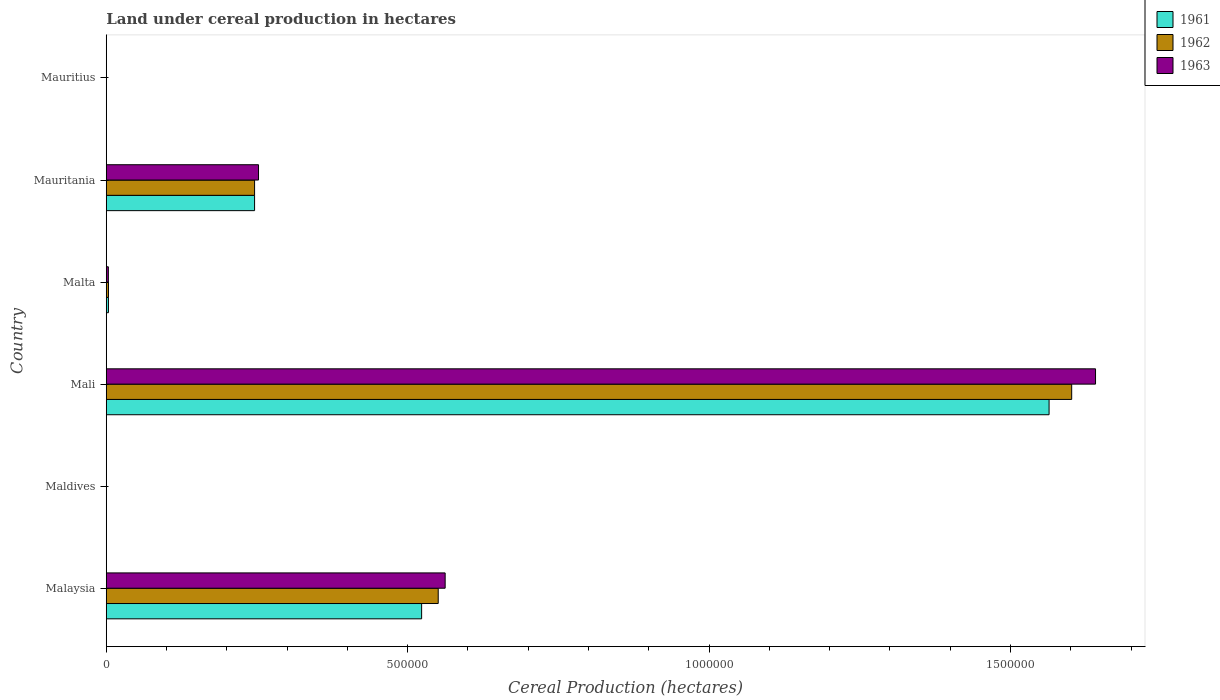How many groups of bars are there?
Your response must be concise. 6. Are the number of bars per tick equal to the number of legend labels?
Offer a very short reply. Yes. Are the number of bars on each tick of the Y-axis equal?
Ensure brevity in your answer.  Yes. How many bars are there on the 4th tick from the bottom?
Ensure brevity in your answer.  3. What is the label of the 6th group of bars from the top?
Give a very brief answer. Malaysia. What is the land under cereal production in 1962 in Maldives?
Your answer should be very brief. 240. Across all countries, what is the maximum land under cereal production in 1962?
Your response must be concise. 1.60e+06. Across all countries, what is the minimum land under cereal production in 1962?
Ensure brevity in your answer.  114. In which country was the land under cereal production in 1961 maximum?
Offer a terse response. Mali. In which country was the land under cereal production in 1961 minimum?
Offer a very short reply. Mauritius. What is the total land under cereal production in 1962 in the graph?
Offer a very short reply. 2.40e+06. What is the difference between the land under cereal production in 1961 in Mali and that in Mauritania?
Keep it short and to the point. 1.32e+06. What is the difference between the land under cereal production in 1963 in Mauritania and the land under cereal production in 1961 in Maldives?
Provide a short and direct response. 2.52e+05. What is the average land under cereal production in 1962 per country?
Your answer should be compact. 4.00e+05. What is the ratio of the land under cereal production in 1963 in Maldives to that in Mauritania?
Offer a terse response. 0. What is the difference between the highest and the second highest land under cereal production in 1961?
Keep it short and to the point. 1.04e+06. What is the difference between the highest and the lowest land under cereal production in 1961?
Keep it short and to the point. 1.56e+06. What does the 1st bar from the top in Maldives represents?
Make the answer very short. 1963. What does the 1st bar from the bottom in Mauritania represents?
Provide a short and direct response. 1961. How many bars are there?
Give a very brief answer. 18. How many countries are there in the graph?
Your answer should be compact. 6. Are the values on the major ticks of X-axis written in scientific E-notation?
Provide a succinct answer. No. Where does the legend appear in the graph?
Provide a succinct answer. Top right. What is the title of the graph?
Offer a terse response. Land under cereal production in hectares. What is the label or title of the X-axis?
Your answer should be very brief. Cereal Production (hectares). What is the Cereal Production (hectares) of 1961 in Malaysia?
Provide a short and direct response. 5.23e+05. What is the Cereal Production (hectares) in 1962 in Malaysia?
Ensure brevity in your answer.  5.51e+05. What is the Cereal Production (hectares) in 1963 in Malaysia?
Offer a terse response. 5.62e+05. What is the Cereal Production (hectares) in 1961 in Maldives?
Provide a succinct answer. 179. What is the Cereal Production (hectares) in 1962 in Maldives?
Your answer should be very brief. 240. What is the Cereal Production (hectares) of 1963 in Maldives?
Give a very brief answer. 292. What is the Cereal Production (hectares) of 1961 in Mali?
Offer a terse response. 1.56e+06. What is the Cereal Production (hectares) in 1962 in Mali?
Provide a short and direct response. 1.60e+06. What is the Cereal Production (hectares) of 1963 in Mali?
Offer a terse response. 1.64e+06. What is the Cereal Production (hectares) of 1961 in Malta?
Provide a short and direct response. 3649. What is the Cereal Production (hectares) of 1962 in Malta?
Offer a terse response. 3699. What is the Cereal Production (hectares) in 1963 in Malta?
Offer a terse response. 3513. What is the Cereal Production (hectares) of 1961 in Mauritania?
Give a very brief answer. 2.46e+05. What is the Cereal Production (hectares) in 1962 in Mauritania?
Your answer should be compact. 2.46e+05. What is the Cereal Production (hectares) of 1963 in Mauritania?
Ensure brevity in your answer.  2.53e+05. What is the Cereal Production (hectares) of 1961 in Mauritius?
Provide a succinct answer. 119. What is the Cereal Production (hectares) in 1962 in Mauritius?
Your answer should be compact. 114. What is the Cereal Production (hectares) of 1963 in Mauritius?
Make the answer very short. 114. Across all countries, what is the maximum Cereal Production (hectares) of 1961?
Ensure brevity in your answer.  1.56e+06. Across all countries, what is the maximum Cereal Production (hectares) of 1962?
Provide a short and direct response. 1.60e+06. Across all countries, what is the maximum Cereal Production (hectares) in 1963?
Your response must be concise. 1.64e+06. Across all countries, what is the minimum Cereal Production (hectares) in 1961?
Provide a succinct answer. 119. Across all countries, what is the minimum Cereal Production (hectares) of 1962?
Offer a terse response. 114. Across all countries, what is the minimum Cereal Production (hectares) of 1963?
Provide a short and direct response. 114. What is the total Cereal Production (hectares) of 1961 in the graph?
Offer a terse response. 2.34e+06. What is the total Cereal Production (hectares) in 1962 in the graph?
Make the answer very short. 2.40e+06. What is the total Cereal Production (hectares) of 1963 in the graph?
Give a very brief answer. 2.46e+06. What is the difference between the Cereal Production (hectares) of 1961 in Malaysia and that in Maldives?
Keep it short and to the point. 5.23e+05. What is the difference between the Cereal Production (hectares) in 1962 in Malaysia and that in Maldives?
Your response must be concise. 5.50e+05. What is the difference between the Cereal Production (hectares) of 1963 in Malaysia and that in Maldives?
Your answer should be very brief. 5.62e+05. What is the difference between the Cereal Production (hectares) in 1961 in Malaysia and that in Mali?
Provide a succinct answer. -1.04e+06. What is the difference between the Cereal Production (hectares) of 1962 in Malaysia and that in Mali?
Provide a succinct answer. -1.05e+06. What is the difference between the Cereal Production (hectares) of 1963 in Malaysia and that in Mali?
Make the answer very short. -1.08e+06. What is the difference between the Cereal Production (hectares) in 1961 in Malaysia and that in Malta?
Give a very brief answer. 5.20e+05. What is the difference between the Cereal Production (hectares) of 1962 in Malaysia and that in Malta?
Keep it short and to the point. 5.47e+05. What is the difference between the Cereal Production (hectares) of 1963 in Malaysia and that in Malta?
Provide a succinct answer. 5.59e+05. What is the difference between the Cereal Production (hectares) in 1961 in Malaysia and that in Mauritania?
Your answer should be very brief. 2.77e+05. What is the difference between the Cereal Production (hectares) in 1962 in Malaysia and that in Mauritania?
Offer a very short reply. 3.05e+05. What is the difference between the Cereal Production (hectares) of 1963 in Malaysia and that in Mauritania?
Give a very brief answer. 3.10e+05. What is the difference between the Cereal Production (hectares) in 1961 in Malaysia and that in Mauritius?
Your answer should be very brief. 5.23e+05. What is the difference between the Cereal Production (hectares) in 1962 in Malaysia and that in Mauritius?
Give a very brief answer. 5.51e+05. What is the difference between the Cereal Production (hectares) of 1963 in Malaysia and that in Mauritius?
Your answer should be very brief. 5.62e+05. What is the difference between the Cereal Production (hectares) in 1961 in Maldives and that in Mali?
Ensure brevity in your answer.  -1.56e+06. What is the difference between the Cereal Production (hectares) of 1962 in Maldives and that in Mali?
Make the answer very short. -1.60e+06. What is the difference between the Cereal Production (hectares) in 1963 in Maldives and that in Mali?
Offer a very short reply. -1.64e+06. What is the difference between the Cereal Production (hectares) of 1961 in Maldives and that in Malta?
Provide a succinct answer. -3470. What is the difference between the Cereal Production (hectares) in 1962 in Maldives and that in Malta?
Your answer should be very brief. -3459. What is the difference between the Cereal Production (hectares) of 1963 in Maldives and that in Malta?
Keep it short and to the point. -3221. What is the difference between the Cereal Production (hectares) in 1961 in Maldives and that in Mauritania?
Keep it short and to the point. -2.46e+05. What is the difference between the Cereal Production (hectares) in 1962 in Maldives and that in Mauritania?
Your response must be concise. -2.46e+05. What is the difference between the Cereal Production (hectares) of 1963 in Maldives and that in Mauritania?
Offer a very short reply. -2.52e+05. What is the difference between the Cereal Production (hectares) of 1962 in Maldives and that in Mauritius?
Your response must be concise. 126. What is the difference between the Cereal Production (hectares) in 1963 in Maldives and that in Mauritius?
Keep it short and to the point. 178. What is the difference between the Cereal Production (hectares) of 1961 in Mali and that in Malta?
Provide a short and direct response. 1.56e+06. What is the difference between the Cereal Production (hectares) in 1962 in Mali and that in Malta?
Offer a very short reply. 1.60e+06. What is the difference between the Cereal Production (hectares) of 1963 in Mali and that in Malta?
Your response must be concise. 1.64e+06. What is the difference between the Cereal Production (hectares) in 1961 in Mali and that in Mauritania?
Ensure brevity in your answer.  1.32e+06. What is the difference between the Cereal Production (hectares) of 1962 in Mali and that in Mauritania?
Offer a very short reply. 1.36e+06. What is the difference between the Cereal Production (hectares) in 1963 in Mali and that in Mauritania?
Your response must be concise. 1.39e+06. What is the difference between the Cereal Production (hectares) of 1961 in Mali and that in Mauritius?
Provide a succinct answer. 1.56e+06. What is the difference between the Cereal Production (hectares) in 1962 in Mali and that in Mauritius?
Keep it short and to the point. 1.60e+06. What is the difference between the Cereal Production (hectares) in 1963 in Mali and that in Mauritius?
Provide a succinct answer. 1.64e+06. What is the difference between the Cereal Production (hectares) in 1961 in Malta and that in Mauritania?
Give a very brief answer. -2.42e+05. What is the difference between the Cereal Production (hectares) in 1962 in Malta and that in Mauritania?
Give a very brief answer. -2.42e+05. What is the difference between the Cereal Production (hectares) in 1963 in Malta and that in Mauritania?
Make the answer very short. -2.49e+05. What is the difference between the Cereal Production (hectares) of 1961 in Malta and that in Mauritius?
Provide a succinct answer. 3530. What is the difference between the Cereal Production (hectares) in 1962 in Malta and that in Mauritius?
Give a very brief answer. 3585. What is the difference between the Cereal Production (hectares) in 1963 in Malta and that in Mauritius?
Provide a succinct answer. 3399. What is the difference between the Cereal Production (hectares) in 1961 in Mauritania and that in Mauritius?
Give a very brief answer. 2.46e+05. What is the difference between the Cereal Production (hectares) of 1962 in Mauritania and that in Mauritius?
Provide a short and direct response. 2.46e+05. What is the difference between the Cereal Production (hectares) in 1963 in Mauritania and that in Mauritius?
Offer a very short reply. 2.52e+05. What is the difference between the Cereal Production (hectares) of 1961 in Malaysia and the Cereal Production (hectares) of 1962 in Maldives?
Provide a succinct answer. 5.23e+05. What is the difference between the Cereal Production (hectares) in 1961 in Malaysia and the Cereal Production (hectares) in 1963 in Maldives?
Provide a succinct answer. 5.23e+05. What is the difference between the Cereal Production (hectares) of 1962 in Malaysia and the Cereal Production (hectares) of 1963 in Maldives?
Your answer should be very brief. 5.50e+05. What is the difference between the Cereal Production (hectares) in 1961 in Malaysia and the Cereal Production (hectares) in 1962 in Mali?
Keep it short and to the point. -1.08e+06. What is the difference between the Cereal Production (hectares) of 1961 in Malaysia and the Cereal Production (hectares) of 1963 in Mali?
Ensure brevity in your answer.  -1.12e+06. What is the difference between the Cereal Production (hectares) in 1962 in Malaysia and the Cereal Production (hectares) in 1963 in Mali?
Make the answer very short. -1.09e+06. What is the difference between the Cereal Production (hectares) in 1961 in Malaysia and the Cereal Production (hectares) in 1962 in Malta?
Provide a succinct answer. 5.19e+05. What is the difference between the Cereal Production (hectares) in 1961 in Malaysia and the Cereal Production (hectares) in 1963 in Malta?
Your answer should be compact. 5.20e+05. What is the difference between the Cereal Production (hectares) of 1962 in Malaysia and the Cereal Production (hectares) of 1963 in Malta?
Your answer should be very brief. 5.47e+05. What is the difference between the Cereal Production (hectares) in 1961 in Malaysia and the Cereal Production (hectares) in 1962 in Mauritania?
Offer a very short reply. 2.77e+05. What is the difference between the Cereal Production (hectares) of 1961 in Malaysia and the Cereal Production (hectares) of 1963 in Mauritania?
Provide a short and direct response. 2.71e+05. What is the difference between the Cereal Production (hectares) in 1962 in Malaysia and the Cereal Production (hectares) in 1963 in Mauritania?
Ensure brevity in your answer.  2.98e+05. What is the difference between the Cereal Production (hectares) in 1961 in Malaysia and the Cereal Production (hectares) in 1962 in Mauritius?
Keep it short and to the point. 5.23e+05. What is the difference between the Cereal Production (hectares) in 1961 in Malaysia and the Cereal Production (hectares) in 1963 in Mauritius?
Your answer should be very brief. 5.23e+05. What is the difference between the Cereal Production (hectares) in 1962 in Malaysia and the Cereal Production (hectares) in 1963 in Mauritius?
Provide a short and direct response. 5.51e+05. What is the difference between the Cereal Production (hectares) in 1961 in Maldives and the Cereal Production (hectares) in 1962 in Mali?
Provide a short and direct response. -1.60e+06. What is the difference between the Cereal Production (hectares) of 1961 in Maldives and the Cereal Production (hectares) of 1963 in Mali?
Make the answer very short. -1.64e+06. What is the difference between the Cereal Production (hectares) of 1962 in Maldives and the Cereal Production (hectares) of 1963 in Mali?
Keep it short and to the point. -1.64e+06. What is the difference between the Cereal Production (hectares) of 1961 in Maldives and the Cereal Production (hectares) of 1962 in Malta?
Offer a very short reply. -3520. What is the difference between the Cereal Production (hectares) of 1961 in Maldives and the Cereal Production (hectares) of 1963 in Malta?
Ensure brevity in your answer.  -3334. What is the difference between the Cereal Production (hectares) in 1962 in Maldives and the Cereal Production (hectares) in 1963 in Malta?
Your answer should be compact. -3273. What is the difference between the Cereal Production (hectares) of 1961 in Maldives and the Cereal Production (hectares) of 1962 in Mauritania?
Offer a terse response. -2.46e+05. What is the difference between the Cereal Production (hectares) of 1961 in Maldives and the Cereal Production (hectares) of 1963 in Mauritania?
Keep it short and to the point. -2.52e+05. What is the difference between the Cereal Production (hectares) in 1962 in Maldives and the Cereal Production (hectares) in 1963 in Mauritania?
Keep it short and to the point. -2.52e+05. What is the difference between the Cereal Production (hectares) of 1961 in Maldives and the Cereal Production (hectares) of 1962 in Mauritius?
Make the answer very short. 65. What is the difference between the Cereal Production (hectares) in 1962 in Maldives and the Cereal Production (hectares) in 1963 in Mauritius?
Give a very brief answer. 126. What is the difference between the Cereal Production (hectares) of 1961 in Mali and the Cereal Production (hectares) of 1962 in Malta?
Ensure brevity in your answer.  1.56e+06. What is the difference between the Cereal Production (hectares) of 1961 in Mali and the Cereal Production (hectares) of 1963 in Malta?
Provide a short and direct response. 1.56e+06. What is the difference between the Cereal Production (hectares) in 1962 in Mali and the Cereal Production (hectares) in 1963 in Malta?
Keep it short and to the point. 1.60e+06. What is the difference between the Cereal Production (hectares) in 1961 in Mali and the Cereal Production (hectares) in 1962 in Mauritania?
Provide a succinct answer. 1.32e+06. What is the difference between the Cereal Production (hectares) of 1961 in Mali and the Cereal Production (hectares) of 1963 in Mauritania?
Provide a short and direct response. 1.31e+06. What is the difference between the Cereal Production (hectares) in 1962 in Mali and the Cereal Production (hectares) in 1963 in Mauritania?
Provide a succinct answer. 1.35e+06. What is the difference between the Cereal Production (hectares) in 1961 in Mali and the Cereal Production (hectares) in 1962 in Mauritius?
Ensure brevity in your answer.  1.56e+06. What is the difference between the Cereal Production (hectares) in 1961 in Mali and the Cereal Production (hectares) in 1963 in Mauritius?
Give a very brief answer. 1.56e+06. What is the difference between the Cereal Production (hectares) of 1962 in Mali and the Cereal Production (hectares) of 1963 in Mauritius?
Offer a terse response. 1.60e+06. What is the difference between the Cereal Production (hectares) in 1961 in Malta and the Cereal Production (hectares) in 1962 in Mauritania?
Ensure brevity in your answer.  -2.42e+05. What is the difference between the Cereal Production (hectares) in 1961 in Malta and the Cereal Production (hectares) in 1963 in Mauritania?
Provide a short and direct response. -2.49e+05. What is the difference between the Cereal Production (hectares) of 1962 in Malta and the Cereal Production (hectares) of 1963 in Mauritania?
Give a very brief answer. -2.49e+05. What is the difference between the Cereal Production (hectares) in 1961 in Malta and the Cereal Production (hectares) in 1962 in Mauritius?
Ensure brevity in your answer.  3535. What is the difference between the Cereal Production (hectares) in 1961 in Malta and the Cereal Production (hectares) in 1963 in Mauritius?
Make the answer very short. 3535. What is the difference between the Cereal Production (hectares) of 1962 in Malta and the Cereal Production (hectares) of 1963 in Mauritius?
Your answer should be very brief. 3585. What is the difference between the Cereal Production (hectares) in 1961 in Mauritania and the Cereal Production (hectares) in 1962 in Mauritius?
Offer a very short reply. 2.46e+05. What is the difference between the Cereal Production (hectares) of 1961 in Mauritania and the Cereal Production (hectares) of 1963 in Mauritius?
Provide a succinct answer. 2.46e+05. What is the difference between the Cereal Production (hectares) in 1962 in Mauritania and the Cereal Production (hectares) in 1963 in Mauritius?
Your answer should be compact. 2.46e+05. What is the average Cereal Production (hectares) in 1961 per country?
Provide a succinct answer. 3.90e+05. What is the average Cereal Production (hectares) of 1962 per country?
Offer a very short reply. 4.00e+05. What is the average Cereal Production (hectares) in 1963 per country?
Provide a short and direct response. 4.10e+05. What is the difference between the Cereal Production (hectares) of 1961 and Cereal Production (hectares) of 1962 in Malaysia?
Ensure brevity in your answer.  -2.75e+04. What is the difference between the Cereal Production (hectares) in 1961 and Cereal Production (hectares) in 1963 in Malaysia?
Your answer should be very brief. -3.90e+04. What is the difference between the Cereal Production (hectares) of 1962 and Cereal Production (hectares) of 1963 in Malaysia?
Give a very brief answer. -1.15e+04. What is the difference between the Cereal Production (hectares) in 1961 and Cereal Production (hectares) in 1962 in Maldives?
Your response must be concise. -61. What is the difference between the Cereal Production (hectares) of 1961 and Cereal Production (hectares) of 1963 in Maldives?
Ensure brevity in your answer.  -113. What is the difference between the Cereal Production (hectares) of 1962 and Cereal Production (hectares) of 1963 in Maldives?
Provide a succinct answer. -52. What is the difference between the Cereal Production (hectares) of 1961 and Cereal Production (hectares) of 1962 in Mali?
Your response must be concise. -3.75e+04. What is the difference between the Cereal Production (hectares) of 1961 and Cereal Production (hectares) of 1963 in Mali?
Provide a succinct answer. -7.71e+04. What is the difference between the Cereal Production (hectares) of 1962 and Cereal Production (hectares) of 1963 in Mali?
Provide a succinct answer. -3.96e+04. What is the difference between the Cereal Production (hectares) of 1961 and Cereal Production (hectares) of 1962 in Malta?
Offer a very short reply. -50. What is the difference between the Cereal Production (hectares) in 1961 and Cereal Production (hectares) in 1963 in Malta?
Give a very brief answer. 136. What is the difference between the Cereal Production (hectares) in 1962 and Cereal Production (hectares) in 1963 in Malta?
Your answer should be very brief. 186. What is the difference between the Cereal Production (hectares) in 1961 and Cereal Production (hectares) in 1962 in Mauritania?
Ensure brevity in your answer.  0. What is the difference between the Cereal Production (hectares) in 1961 and Cereal Production (hectares) in 1963 in Mauritania?
Make the answer very short. -6550. What is the difference between the Cereal Production (hectares) in 1962 and Cereal Production (hectares) in 1963 in Mauritania?
Your answer should be compact. -6550. What is the difference between the Cereal Production (hectares) of 1961 and Cereal Production (hectares) of 1962 in Mauritius?
Ensure brevity in your answer.  5. What is the difference between the Cereal Production (hectares) in 1961 and Cereal Production (hectares) in 1963 in Mauritius?
Make the answer very short. 5. What is the ratio of the Cereal Production (hectares) of 1961 in Malaysia to that in Maldives?
Your answer should be very brief. 2922.64. What is the ratio of the Cereal Production (hectares) of 1962 in Malaysia to that in Maldives?
Your answer should be very brief. 2294.52. What is the ratio of the Cereal Production (hectares) in 1963 in Malaysia to that in Maldives?
Keep it short and to the point. 1925.29. What is the ratio of the Cereal Production (hectares) in 1961 in Malaysia to that in Mali?
Your response must be concise. 0.33. What is the ratio of the Cereal Production (hectares) of 1962 in Malaysia to that in Mali?
Your response must be concise. 0.34. What is the ratio of the Cereal Production (hectares) of 1963 in Malaysia to that in Mali?
Keep it short and to the point. 0.34. What is the ratio of the Cereal Production (hectares) in 1961 in Malaysia to that in Malta?
Give a very brief answer. 143.37. What is the ratio of the Cereal Production (hectares) of 1962 in Malaysia to that in Malta?
Your answer should be compact. 148.87. What is the ratio of the Cereal Production (hectares) in 1963 in Malaysia to that in Malta?
Your answer should be compact. 160.03. What is the ratio of the Cereal Production (hectares) of 1961 in Malaysia to that in Mauritania?
Your answer should be compact. 2.13. What is the ratio of the Cereal Production (hectares) of 1962 in Malaysia to that in Mauritania?
Provide a succinct answer. 2.24. What is the ratio of the Cereal Production (hectares) of 1963 in Malaysia to that in Mauritania?
Give a very brief answer. 2.23. What is the ratio of the Cereal Production (hectares) in 1961 in Malaysia to that in Mauritius?
Keep it short and to the point. 4396.24. What is the ratio of the Cereal Production (hectares) in 1962 in Malaysia to that in Mauritius?
Provide a short and direct response. 4830.56. What is the ratio of the Cereal Production (hectares) in 1963 in Malaysia to that in Mauritius?
Ensure brevity in your answer.  4931.44. What is the ratio of the Cereal Production (hectares) in 1963 in Maldives to that in Mali?
Your answer should be very brief. 0. What is the ratio of the Cereal Production (hectares) in 1961 in Maldives to that in Malta?
Offer a very short reply. 0.05. What is the ratio of the Cereal Production (hectares) of 1962 in Maldives to that in Malta?
Offer a terse response. 0.06. What is the ratio of the Cereal Production (hectares) of 1963 in Maldives to that in Malta?
Keep it short and to the point. 0.08. What is the ratio of the Cereal Production (hectares) in 1961 in Maldives to that in Mauritania?
Offer a terse response. 0. What is the ratio of the Cereal Production (hectares) in 1962 in Maldives to that in Mauritania?
Your answer should be very brief. 0. What is the ratio of the Cereal Production (hectares) of 1963 in Maldives to that in Mauritania?
Give a very brief answer. 0. What is the ratio of the Cereal Production (hectares) in 1961 in Maldives to that in Mauritius?
Your answer should be very brief. 1.5. What is the ratio of the Cereal Production (hectares) of 1962 in Maldives to that in Mauritius?
Offer a very short reply. 2.11. What is the ratio of the Cereal Production (hectares) of 1963 in Maldives to that in Mauritius?
Offer a very short reply. 2.56. What is the ratio of the Cereal Production (hectares) of 1961 in Mali to that in Malta?
Offer a terse response. 428.61. What is the ratio of the Cereal Production (hectares) in 1962 in Mali to that in Malta?
Your response must be concise. 432.95. What is the ratio of the Cereal Production (hectares) in 1963 in Mali to that in Malta?
Provide a succinct answer. 467.14. What is the ratio of the Cereal Production (hectares) of 1961 in Mali to that in Mauritania?
Offer a terse response. 6.36. What is the ratio of the Cereal Production (hectares) in 1962 in Mali to that in Mauritania?
Your answer should be very brief. 6.51. What is the ratio of the Cereal Production (hectares) in 1963 in Mali to that in Mauritania?
Provide a short and direct response. 6.5. What is the ratio of the Cereal Production (hectares) of 1961 in Mali to that in Mauritius?
Your answer should be compact. 1.31e+04. What is the ratio of the Cereal Production (hectares) of 1962 in Mali to that in Mauritius?
Offer a terse response. 1.40e+04. What is the ratio of the Cereal Production (hectares) in 1963 in Mali to that in Mauritius?
Offer a terse response. 1.44e+04. What is the ratio of the Cereal Production (hectares) of 1961 in Malta to that in Mauritania?
Your response must be concise. 0.01. What is the ratio of the Cereal Production (hectares) in 1962 in Malta to that in Mauritania?
Make the answer very short. 0.01. What is the ratio of the Cereal Production (hectares) of 1963 in Malta to that in Mauritania?
Offer a terse response. 0.01. What is the ratio of the Cereal Production (hectares) of 1961 in Malta to that in Mauritius?
Provide a short and direct response. 30.66. What is the ratio of the Cereal Production (hectares) of 1962 in Malta to that in Mauritius?
Make the answer very short. 32.45. What is the ratio of the Cereal Production (hectares) of 1963 in Malta to that in Mauritius?
Offer a very short reply. 30.82. What is the ratio of the Cereal Production (hectares) of 1961 in Mauritania to that in Mauritius?
Provide a succinct answer. 2067.65. What is the ratio of the Cereal Production (hectares) of 1962 in Mauritania to that in Mauritius?
Give a very brief answer. 2158.33. What is the ratio of the Cereal Production (hectares) in 1963 in Mauritania to that in Mauritius?
Your answer should be compact. 2215.79. What is the difference between the highest and the second highest Cereal Production (hectares) in 1961?
Your answer should be compact. 1.04e+06. What is the difference between the highest and the second highest Cereal Production (hectares) of 1962?
Your answer should be compact. 1.05e+06. What is the difference between the highest and the second highest Cereal Production (hectares) of 1963?
Provide a succinct answer. 1.08e+06. What is the difference between the highest and the lowest Cereal Production (hectares) of 1961?
Give a very brief answer. 1.56e+06. What is the difference between the highest and the lowest Cereal Production (hectares) of 1962?
Your answer should be very brief. 1.60e+06. What is the difference between the highest and the lowest Cereal Production (hectares) of 1963?
Keep it short and to the point. 1.64e+06. 